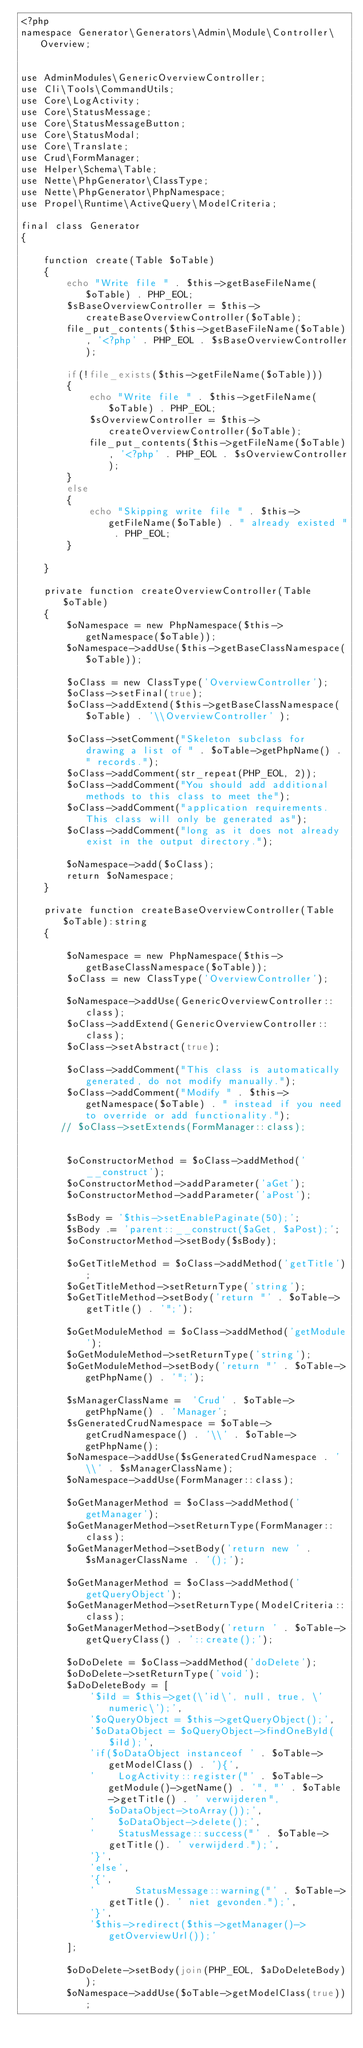<code> <loc_0><loc_0><loc_500><loc_500><_PHP_><?php
namespace Generator\Generators\Admin\Module\Controller\Overview;


use AdminModules\GenericOverviewController;
use Cli\Tools\CommandUtils;
use Core\LogActivity;
use Core\StatusMessage;
use Core\StatusMessageButton;
use Core\StatusModal;
use Core\Translate;
use Crud\FormManager;
use Helper\Schema\Table;
use Nette\PhpGenerator\ClassType;
use Nette\PhpGenerator\PhpNamespace;
use Propel\Runtime\ActiveQuery\ModelCriteria;

final class Generator
{

    function create(Table $oTable)
    {
        echo "Write file " . $this->getBaseFileName($oTable) . PHP_EOL;
        $sBaseOverviewController = $this->createBaseOverviewController($oTable);
        file_put_contents($this->getBaseFileName($oTable), '<?php' . PHP_EOL . $sBaseOverviewController);

        if(!file_exists($this->getFileName($oTable)))
        {
            echo "Write file " . $this->getFileName($oTable) . PHP_EOL;
            $sOverviewController = $this->createOverviewController($oTable);
            file_put_contents($this->getFileName($oTable), '<?php' . PHP_EOL . $sOverviewController);
        }
        else
        {
            echo "Skipping write file " . $this->getFileName($oTable) . " already existed " . PHP_EOL;
        }

    }

    private function createOverviewController(Table $oTable)
    {
        $oNamespace = new PhpNamespace($this->getNamespace($oTable));
        $oNamespace->addUse($this->getBaseClassNamespace($oTable));

        $oClass = new ClassType('OverviewController');
        $oClass->setFinal(true);
        $oClass->addExtend($this->getBaseClassNamespace($oTable) . '\\OverviewController' );

        $oClass->setComment("Skeleton subclass for drawing a list of " . $oTable->getPhpName() . " records.");
        $oClass->addComment(str_repeat(PHP_EOL, 2));
        $oClass->addComment("You should add additional methods to this class to meet the");
        $oClass->addComment("application requirements.  This class will only be generated as");
        $oClass->addComment("long as it does not already exist in the output directory.");

        $oNamespace->add($oClass);
        return $oNamespace;
    }

    private function createBaseOverviewController(Table $oTable):string
    {

        $oNamespace = new PhpNamespace($this->getBaseClassNamespace($oTable));
        $oClass = new ClassType('OverviewController');

        $oNamespace->addUse(GenericOverviewController::class);
        $oClass->addExtend(GenericOverviewController::class);
        $oClass->setAbstract(true);

        $oClass->addComment("This class is automatically generated, do not modify manually.");
        $oClass->addComment("Modify " . $this->getNamespace($oTable) . " instead if you need to override or add functionality.");
       // $oClass->setExtends(FormManager::class);


        $oConstructorMethod = $oClass->addMethod('__construct');
        $oConstructorMethod->addParameter('aGet');
        $oConstructorMethod->addParameter('aPost');

        $sBody = '$this->setEnablePaginate(50);';
        $sBody .= 'parent::__construct($aGet, $aPost);';
        $oConstructorMethod->setBody($sBody);

        $oGetTitleMethod = $oClass->addMethod('getTitle');
        $oGetTitleMethod->setReturnType('string');
        $oGetTitleMethod->setBody('return "' . $oTable->getTitle() . '";');

        $oGetModuleMethod = $oClass->addMethod('getModule');
        $oGetModuleMethod->setReturnType('string');
        $oGetModuleMethod->setBody('return "' . $oTable->getPhpName() . '";');

        $sManagerClassName =  'Crud' . $oTable->getPhpName() . 'Manager';
        $sGeneratedCrudNamespace = $oTable->getCrudNamespace() . '\\' . $oTable->getPhpName();
        $oNamespace->addUse($sGeneratedCrudNamespace . '\\' . $sManagerClassName);
        $oNamespace->addUse(FormManager::class);

        $oGetManagerMethod = $oClass->addMethod('getManager');
        $oGetManagerMethod->setReturnType(FormManager::class);
        $oGetManagerMethod->setBody('return new ' . $sManagerClassName . '();');

        $oGetManagerMethod = $oClass->addMethod('getQueryObject');
        $oGetManagerMethod->setReturnType(ModelCriteria::class);
        $oGetManagerMethod->setBody('return ' . $oTable->getQueryClass() . '::create();');

        $oDoDelete = $oClass->addMethod('doDelete');
        $oDoDelete->setReturnType('void');
        $aDoDeleteBody = [
            '$iId = $this->get(\'id\', null, true, \'numeric\');',
            '$oQueryObject = $this->getQueryObject();',
            '$oDataObject = $oQueryObject->findOneById($iId);',
            'if($oDataObject instanceof ' . $oTable->getModelClass() . '){',
            '    LogActivity::register("' . $oTable->getModule()->getName() . '", "' . $oTable->getTitle() . ' verwijderen", $oDataObject->toArray());',
            '    $oDataObject->delete();',
            '    StatusMessage::success("' . $oTable->getTitle(). ' verwijderd.");',
            '}',
            'else',
            '{',
            '       StatusMessage::warning("' . $oTable->getTitle(). ' niet gevonden.");',
            '}',
            '$this->redirect($this->getManager()->getOverviewUrl());'
        ];

        $oDoDelete->setBody(join(PHP_EOL, $aDoDeleteBody));
        $oNamespace->addUse($oTable->getModelClass(true));
</code> 